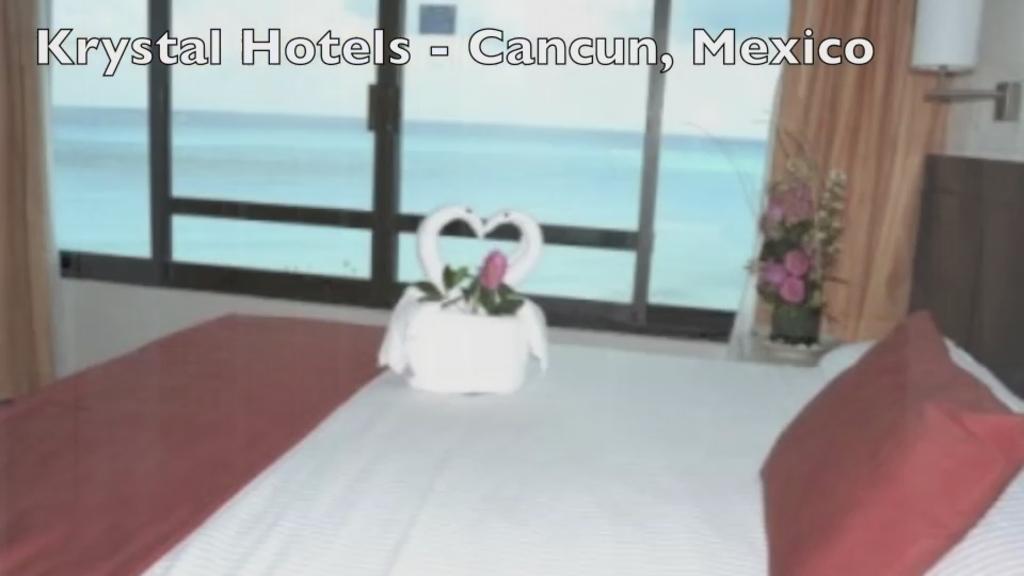Describe this image in one or two sentences. In this image we can see there is a pillow and an object on the bed. There is a houseplant. There are curtains and glass windows.   